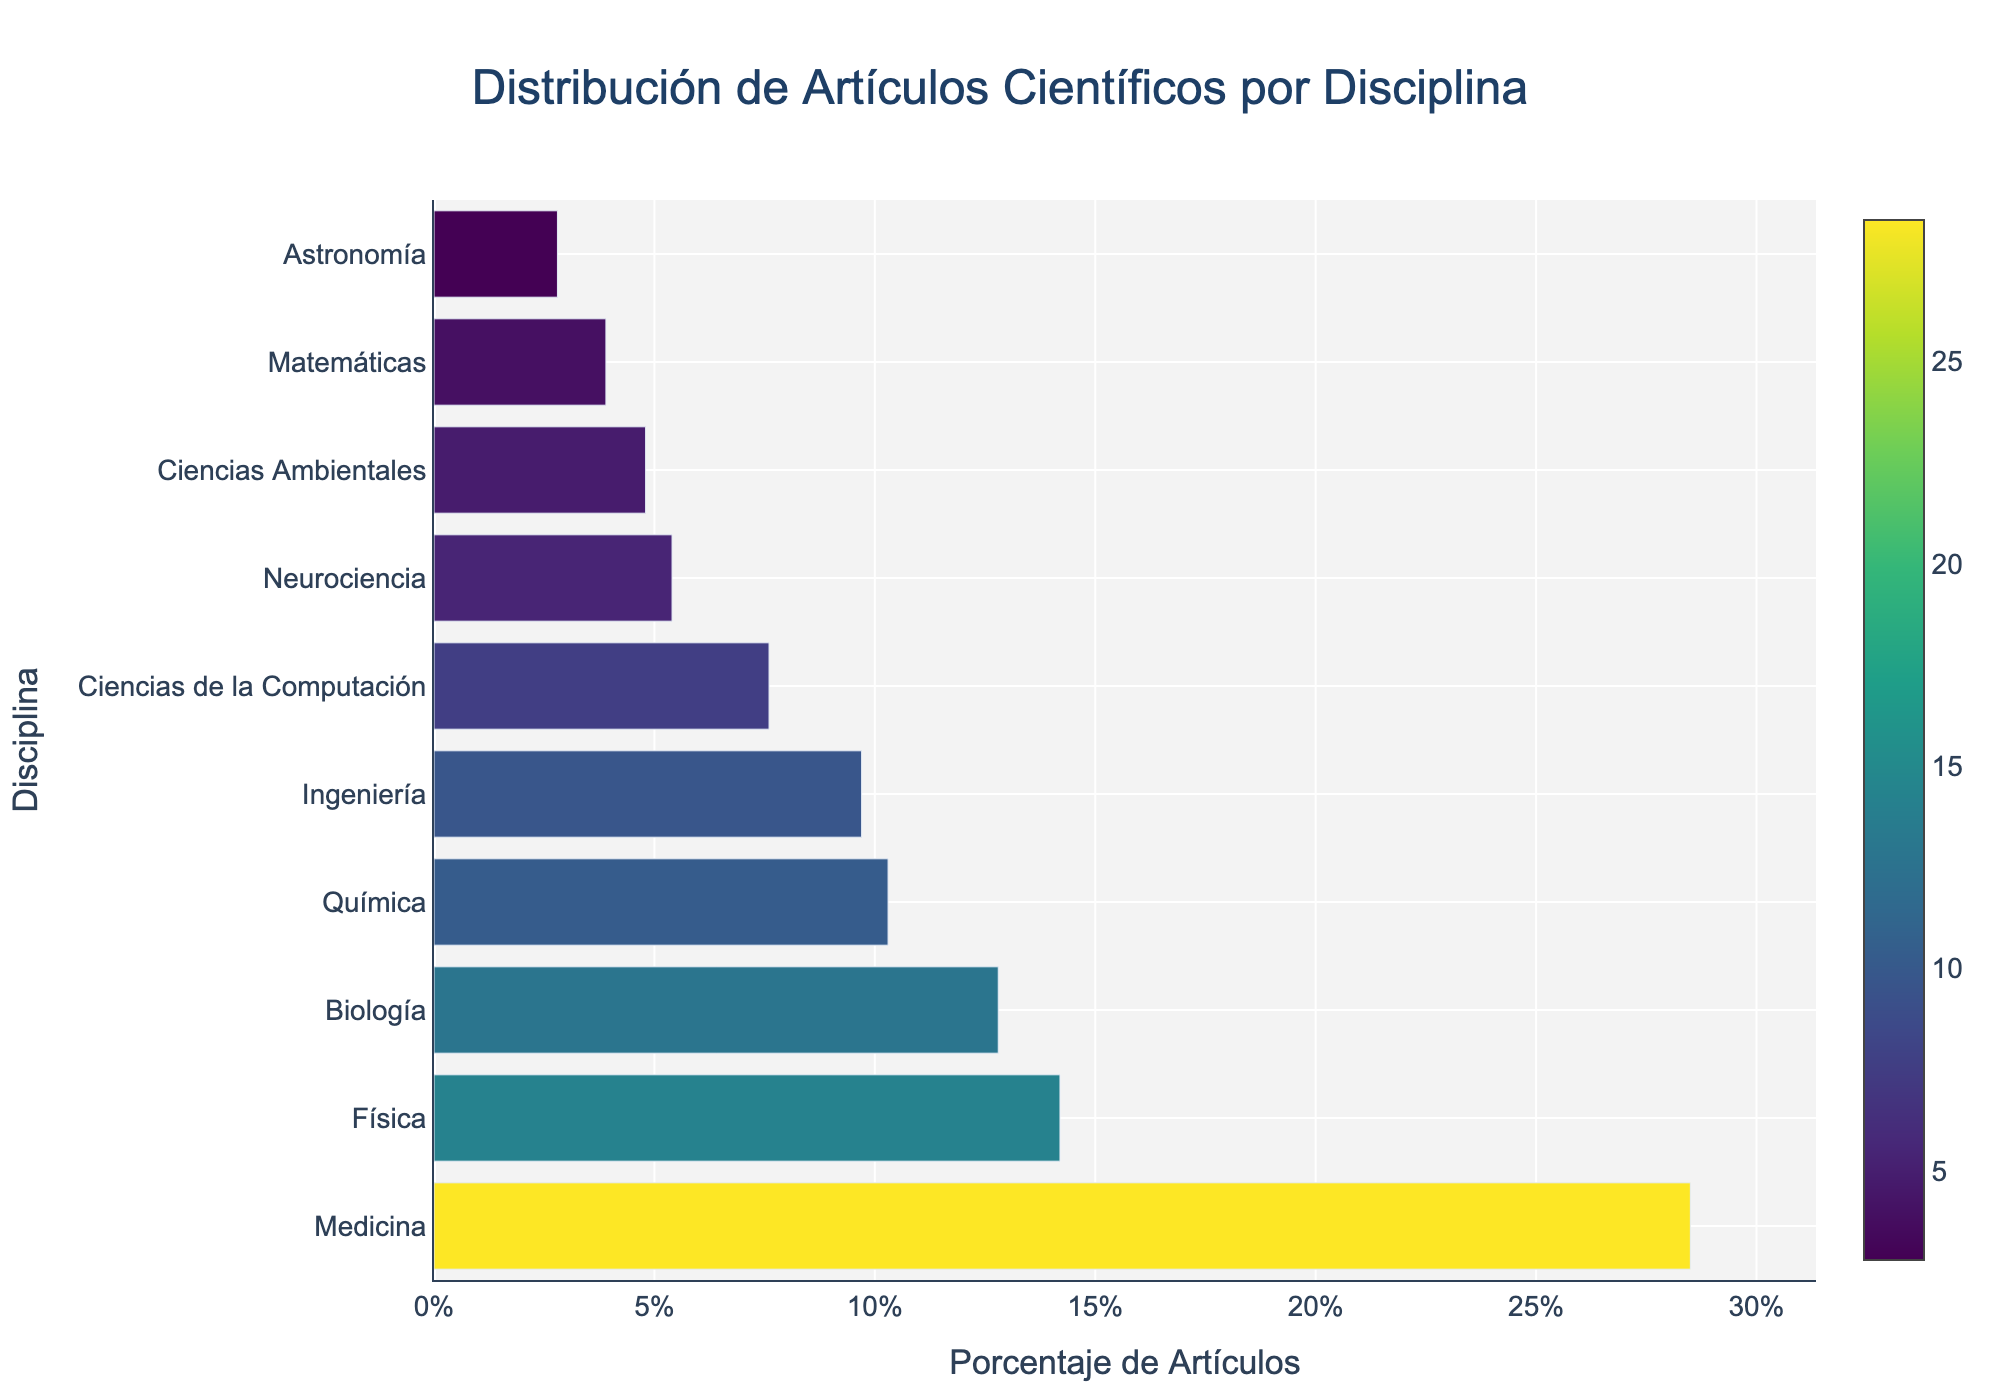What disciplina has the highest percentage of artículos científicos publicados in revistas de alto impacto? The bar representing Medicina is the longest in the chart, indicating that it has the highest percentage.
Answer: Medicina Which disciplina has the lowest percentage of artículos científicos publicados? The bar representing Astronomía is the shortest in the chart, meaning it has the lowest percentage.
Answer: Astronomía What is the difference in percentage of artículos científicos publicados between Física and Química? From the figure, Física has a percentage of 14.2% and Química has 10.3%. The difference is calculated as 14.2% - 10.3%.
Answer: 3.9% Order disciplines by the proportion of artículos científicos publicados from highest to lowest. The chart lists Medicina, Física, Biología, Química, Ingeniería, Ciencias de la Computación, Neurociencia, Ciencias Ambientales, Matemáticas, and Astronomía from top to bottom in descending order.
Answer: Medicina, Física, Biología, Química, Ingeniería, Ciencias de la Computación, Neurociencia, Ciencias Ambientales, Matemáticas, Astronomía How many disciplines have a greater percentage of artículos científicos publicados than Ciencias Ambientales? By looking at the chart, Medicina, Física, Biología, Química, Ingeniería, Ciencias de la Computación, and Neurociencia have higher percentages than Ciencias Ambientales. This counts to seven disciplines.
Answer: 7 What is the average percentage of artículos científicos publicados for Biología, Ingeniería, and Ciencias de la Computación? The percentages from the chart are Biología: 12.8%, Ingeniería: 9.7%, Ciencias de la Computación: 7.6%. The average is calculated as (12.8 + 9.7 + 7.6)/3.
Answer: 10.03% Is the percentage of artículos científicos publicados in Neurociencia less than Ciencias Ambientales? From the chart, Neurociencia has a percentage of 5.4% and Ciencias Ambientales has 4.8%. Since 5.4% is greater than 4.8%, Neurociencia is not less.
Answer: No Combine the percentages of the disciplines with less than 5% of artículos científicos publicados. What is the total? The chart shows Neurociencia: 5.4%, Ciencias Ambientales: 4.8%, Matemáticas: 3.9%, Astronomía: 2.8%. The sum of these percentages is 5.4 + 4.8 + 3.9 + 2.8.
Answer: 16.9% Which has a higher percentage of artículos científicos publicados, Física or Biología? From the figure, Física has 14.2% and Biología has 12.8%. Comparing these, Física has a higher percentage.
Answer: Física How many disciplines have a percentage greater than 10%? From the chart, Medicina, Física, Biología, and Química have percentages higher than 10%. There are four disciplines in total.
Answer: 4 